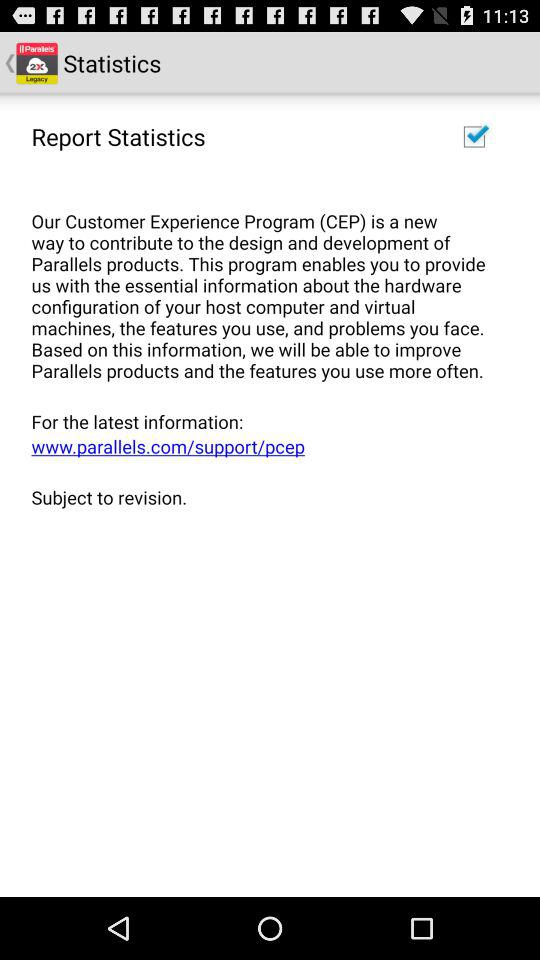What's the website address for the latest information? The website address for the latest information is www.parallels.com/support/pcep. 